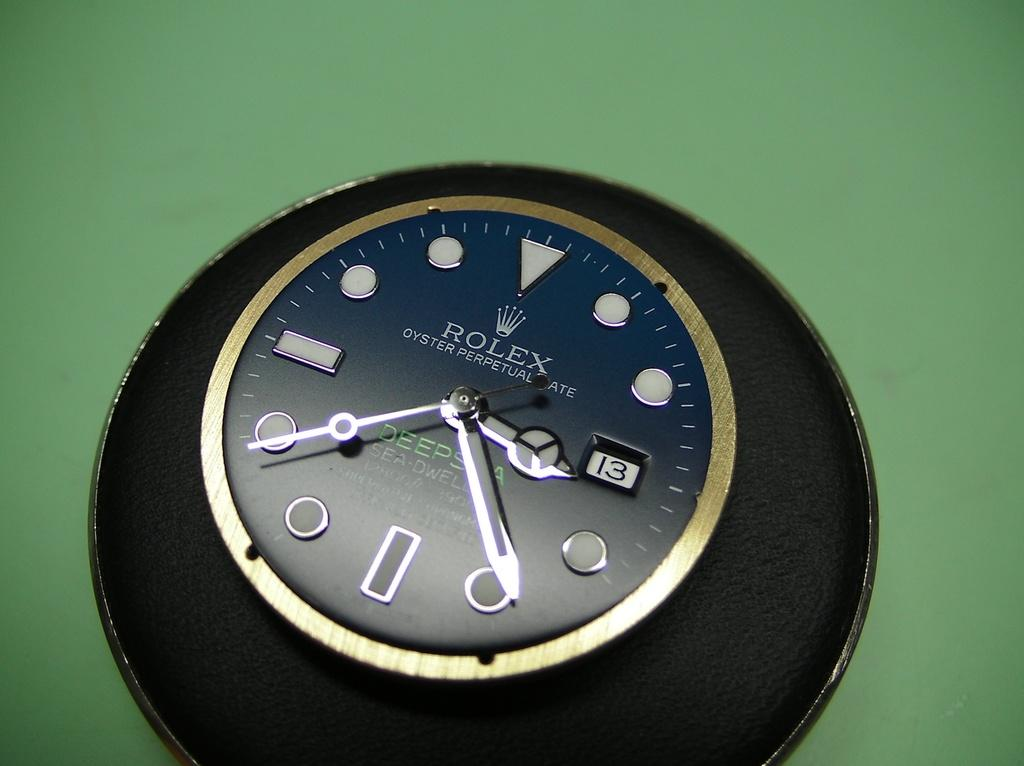<image>
Relay a brief, clear account of the picture shown. A Rolex watch with hands set to read twenty minutes to five. 